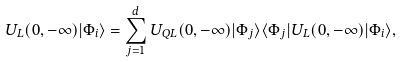Convert formula to latex. <formula><loc_0><loc_0><loc_500><loc_500>U _ { L } ( 0 , - \infty ) | \Phi _ { i } \rangle = \sum _ { j = 1 } ^ { d } U _ { Q L } ( 0 , - \infty ) | \Phi _ { j } \rangle \langle \Phi _ { j } | U _ { L } ( 0 , - \infty ) | \Phi _ { i } \rangle ,</formula> 